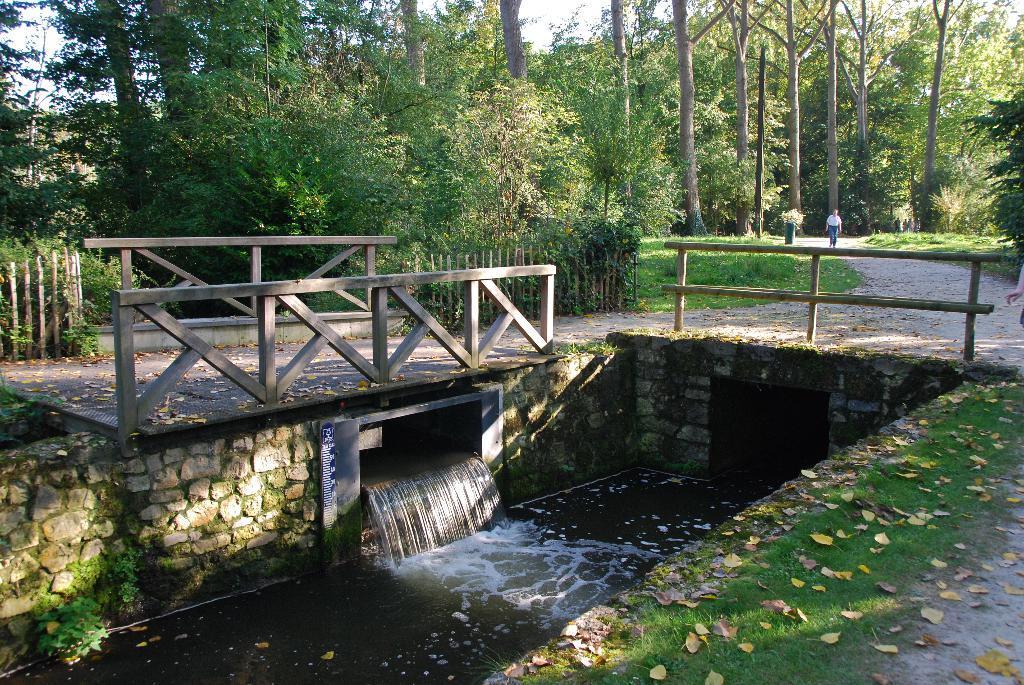How would you summarize this image in a sentence or two? In the center of the image there is water. There is a wooden bridge. In the background of the image there are trees. There is a person walking. At the bottom of the image there is grass and leaves. 